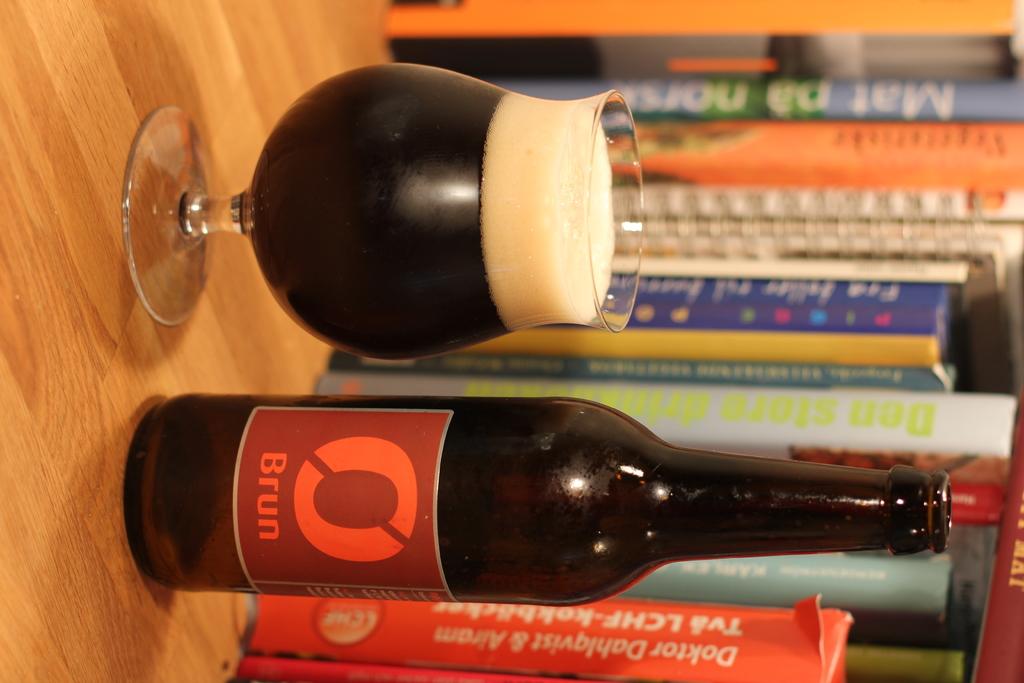What is the name of that orange book at the bottom?
Give a very brief answer. Unanswerable. 